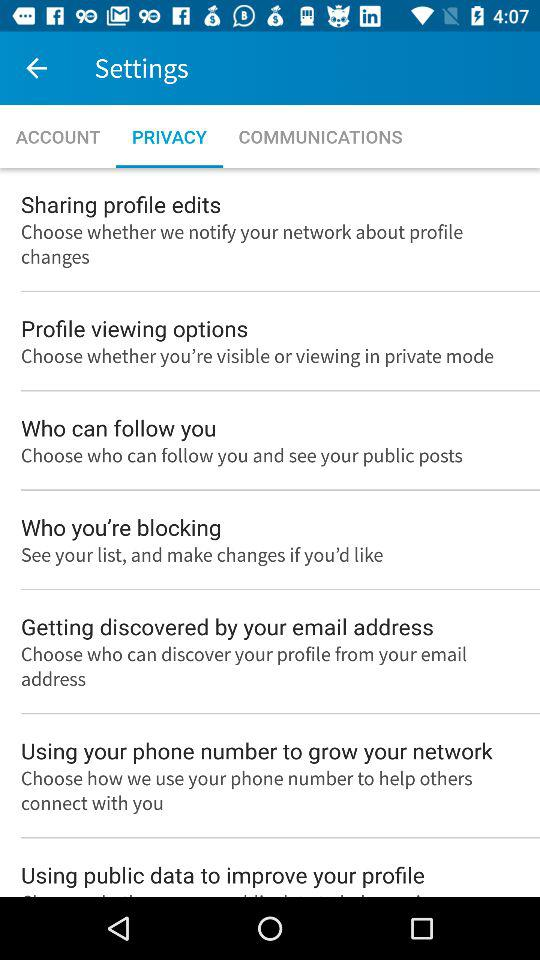At which tab of settings am I? You are at "PRIVACY" tab. 